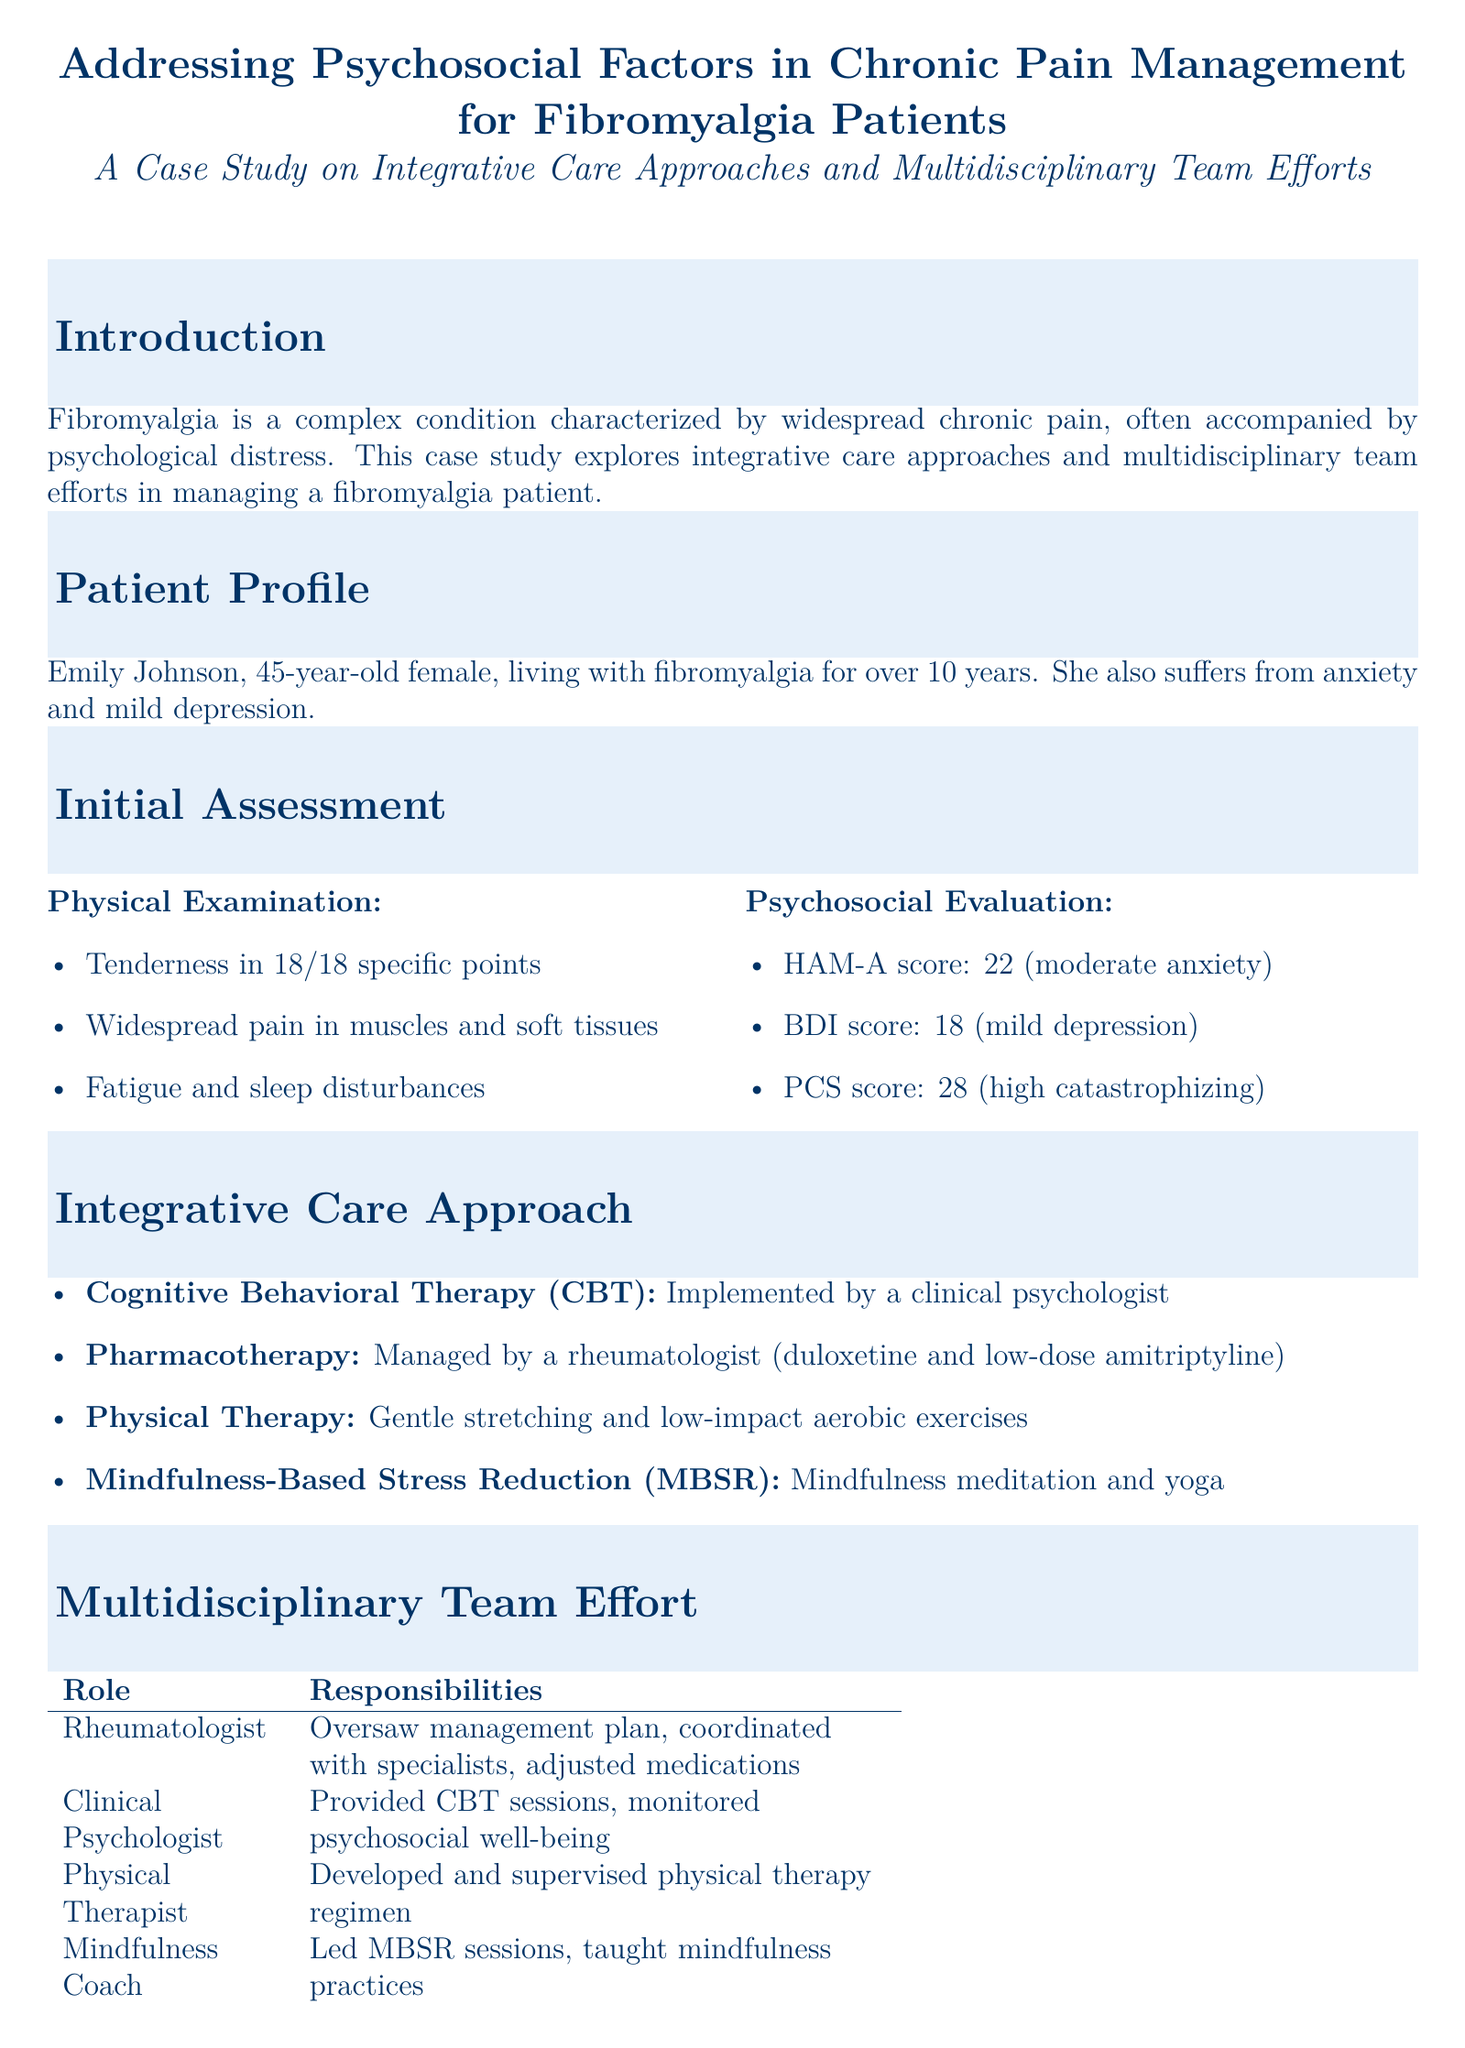What is the patient's age? The document states that Emily Johnson is 45 years old.
Answer: 45-year-old What are the main components of the integrative care approach? The document lists cognitive behavioral therapy, pharmacotherapy, physical therapy, and mindfulness-based stress reduction.
Answer: CBT, Pharmacotherapy, Physical Therapy, MBSR What was the initial HAM-A score for Emily Johnson? The document indicates that her HAM-A score was 22.
Answer: 22 What psychological condition does the patient also suffer from? The document states that Emily Johnson suffers from anxiety and mild depression.
Answer: Anxiety and mild depression What was the outcome for the BDI score after treatment? The document mentions that the BDI score dropped to 10 after treatment.
Answer: 10 Who provided the cognitive behavioral therapy? The document specifies that a clinical psychologist implemented the cognitive behavioral therapy.
Answer: Clinical Psychologist What significant change occurred in the PCS score? The document states the PCS score dropped to 15 after treatment.
Answer: 15 How many specific points showed tenderness during the physical examination? The document notes tenderness in 18 specific points during the examination.
Answer: 18 What role did the mindfulness coach play in the multidisciplinary team? The document states that the mindfulness coach led MBSR sessions and taught mindfulness practices.
Answer: Led MBSR sessions 